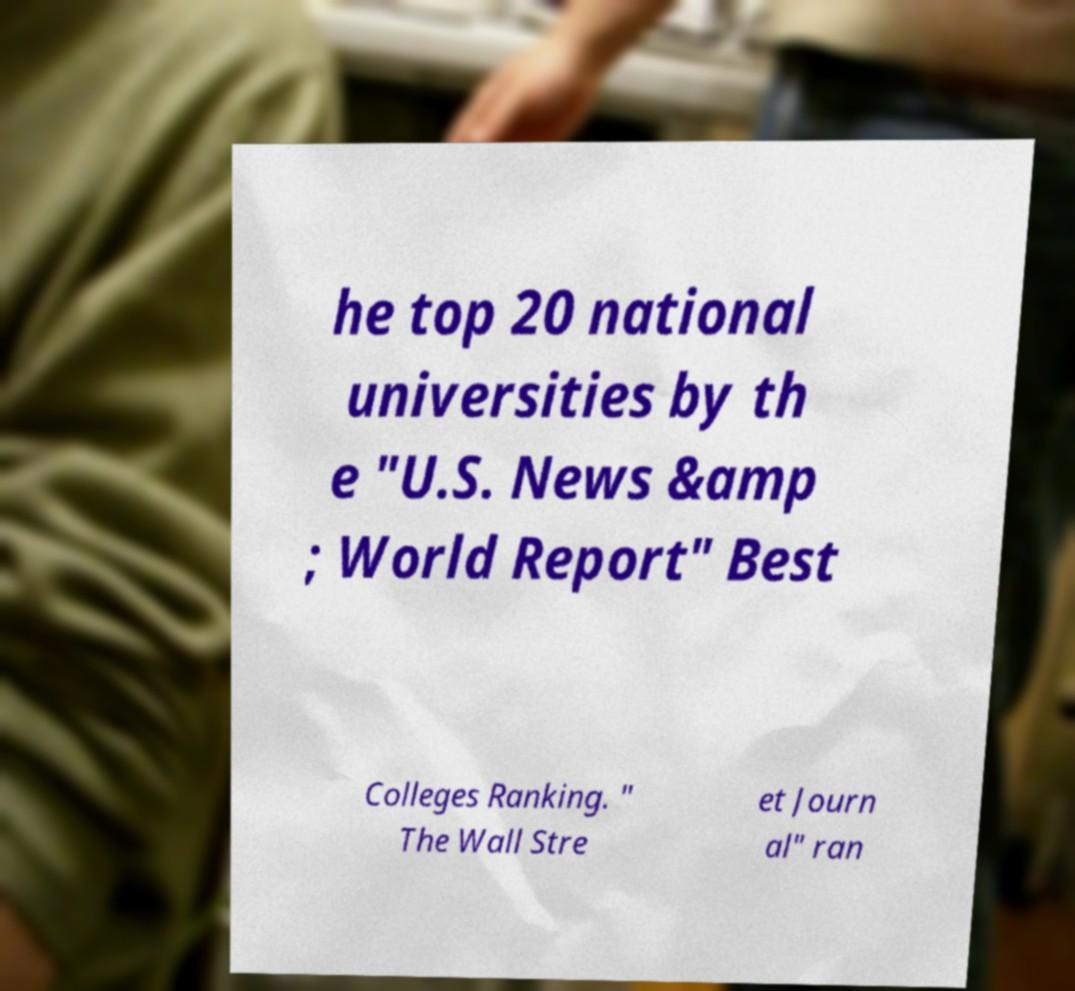Could you extract and type out the text from this image? he top 20 national universities by th e "U.S. News &amp ; World Report" Best Colleges Ranking. " The Wall Stre et Journ al" ran 